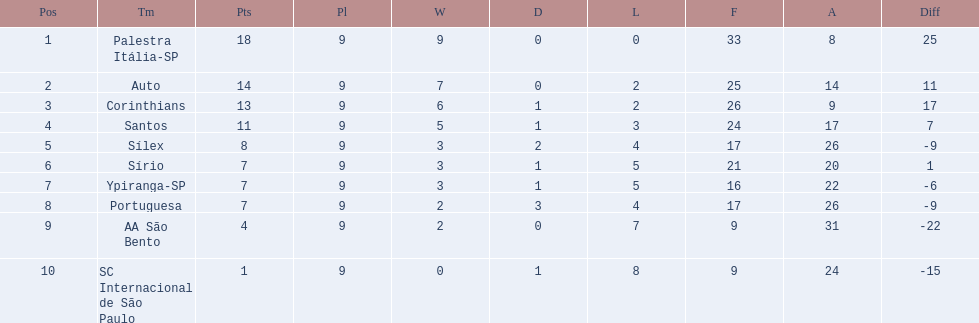How many points were scored by the teams? 18, 14, 13, 11, 8, 7, 7, 7, 4, 1. What team scored 13 points? Corinthians. 